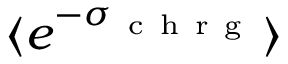<formula> <loc_0><loc_0><loc_500><loc_500>\langle e ^ { - \sigma _ { c h r g } } \rangle</formula> 